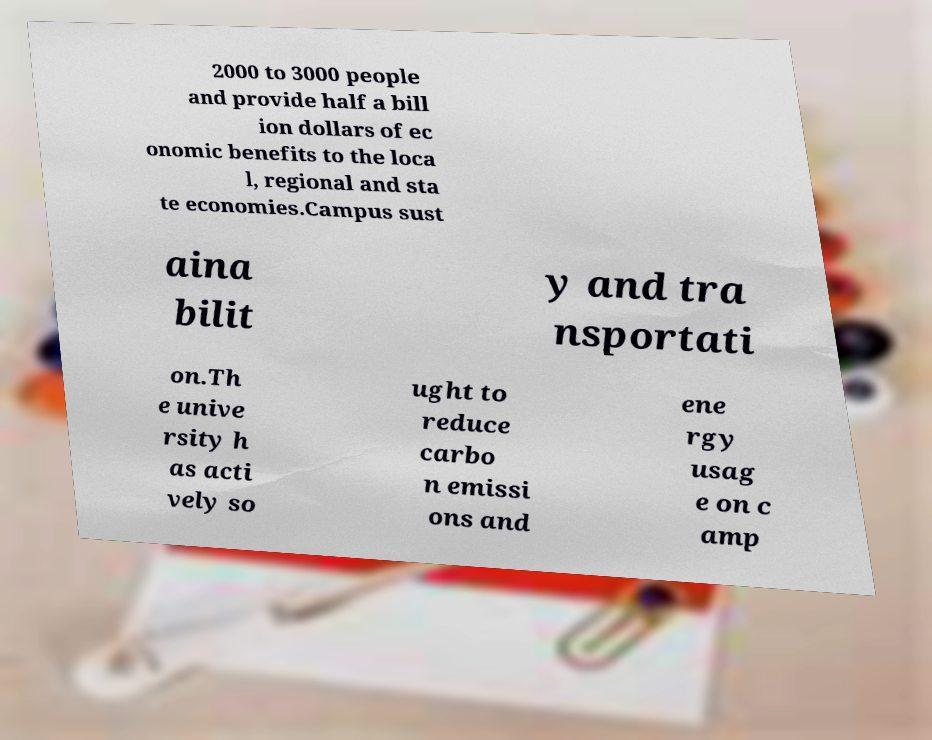Please identify and transcribe the text found in this image. 2000 to 3000 people and provide half a bill ion dollars of ec onomic benefits to the loca l, regional and sta te economies.Campus sust aina bilit y and tra nsportati on.Th e unive rsity h as acti vely so ught to reduce carbo n emissi ons and ene rgy usag e on c amp 